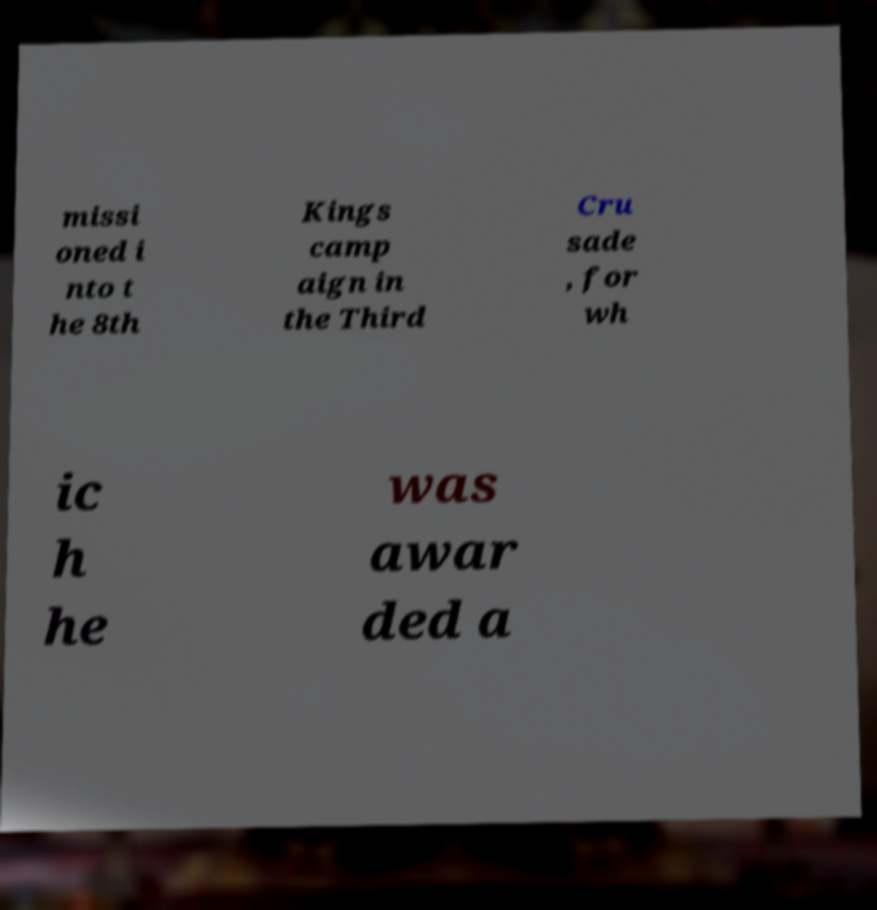Could you extract and type out the text from this image? missi oned i nto t he 8th Kings camp aign in the Third Cru sade , for wh ic h he was awar ded a 